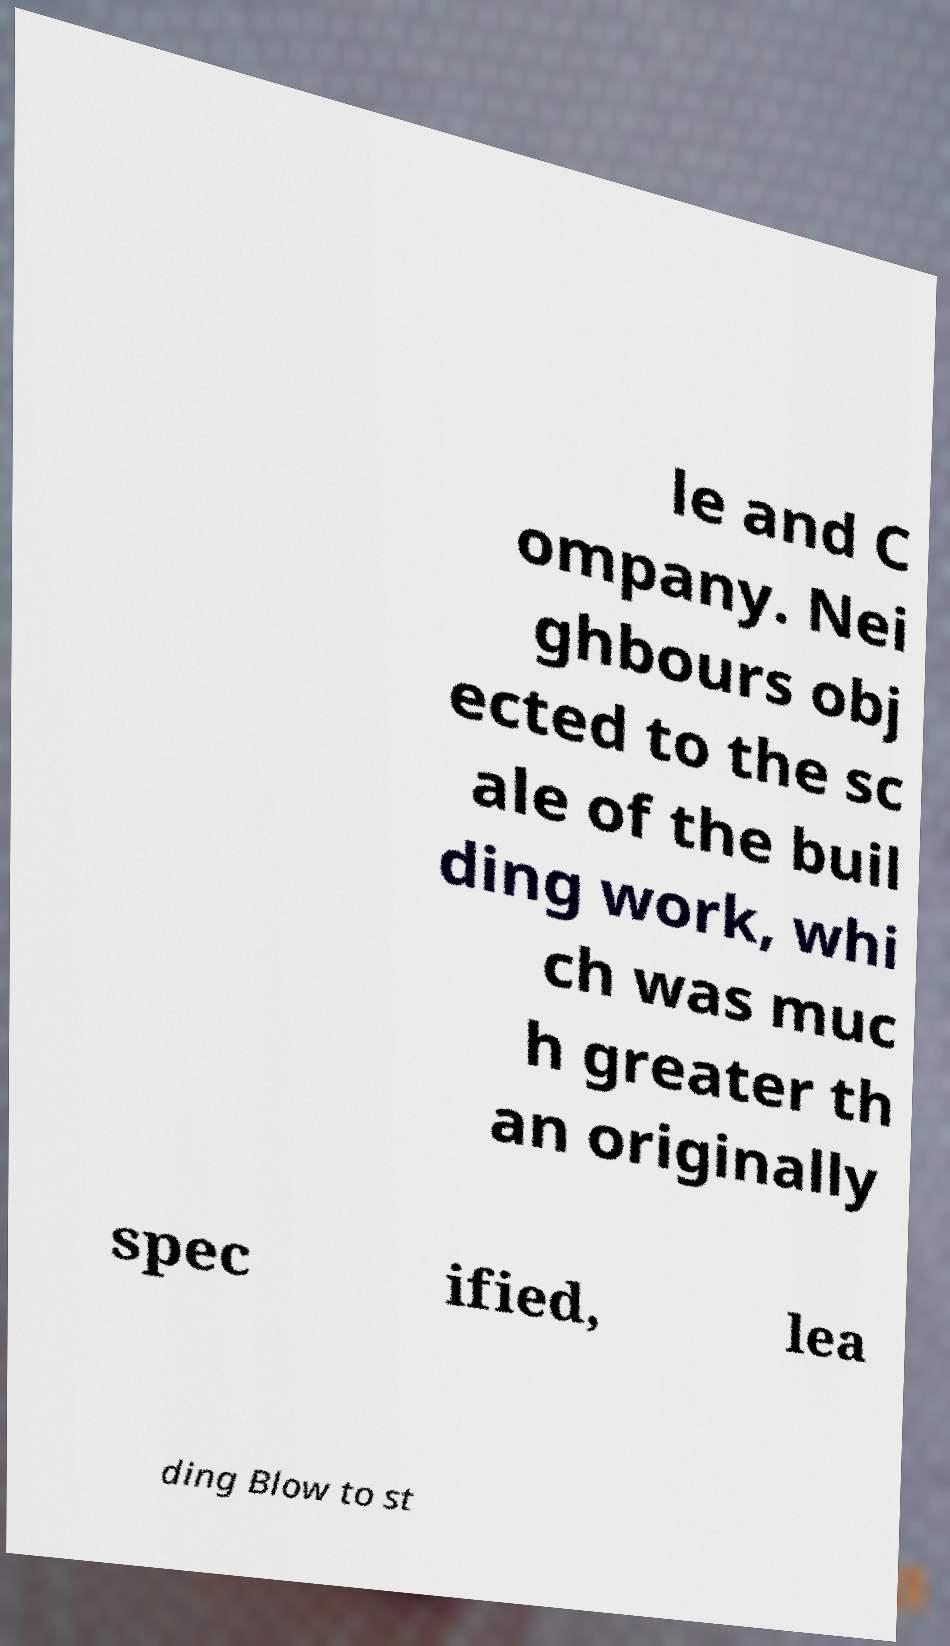I need the written content from this picture converted into text. Can you do that? le and C ompany. Nei ghbours obj ected to the sc ale of the buil ding work, whi ch was muc h greater th an originally spec ified, lea ding Blow to st 